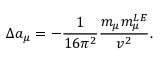<formula> <loc_0><loc_0><loc_500><loc_500>\Delta a _ { \mu } = - \frac { 1 } { 1 6 \pi ^ { 2 } } \frac { m _ { \mu } m _ { \mu } ^ { L E } } { v ^ { 2 } } .</formula> 